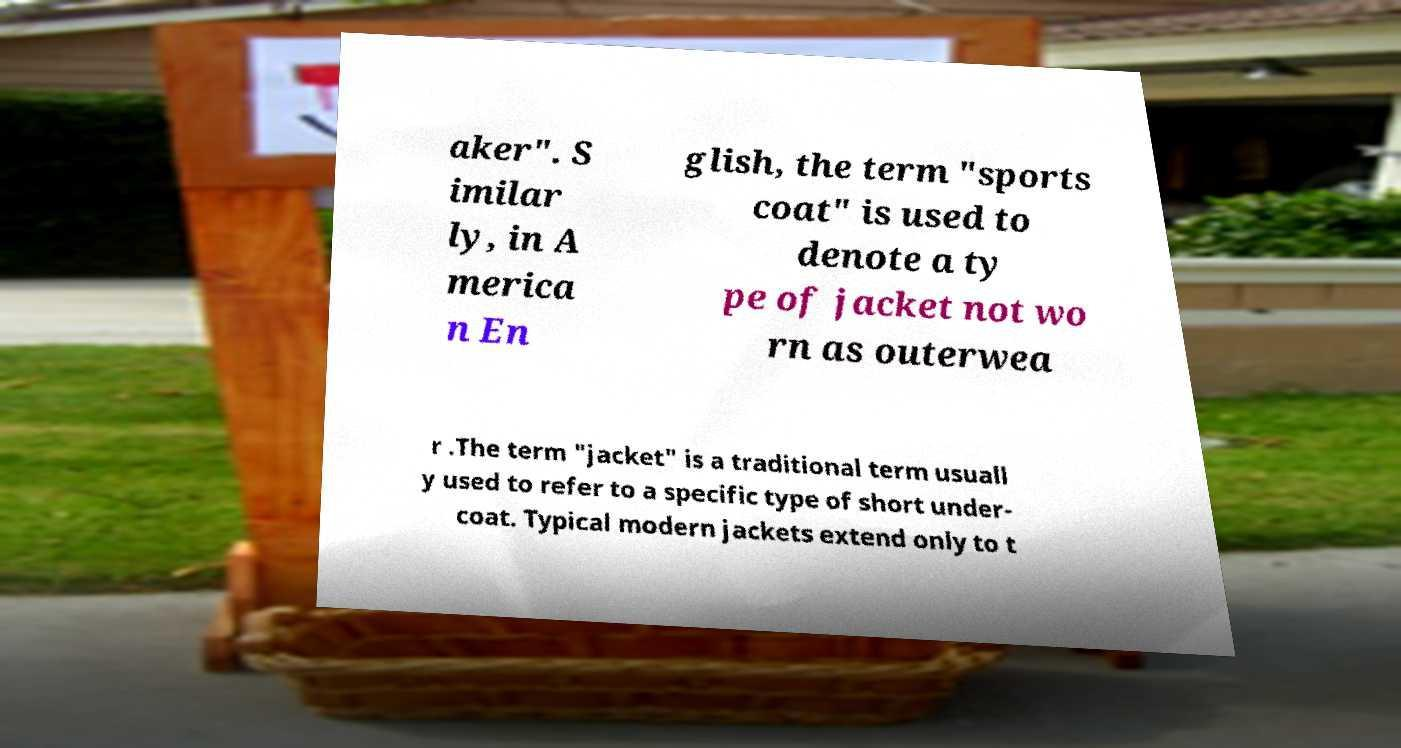For documentation purposes, I need the text within this image transcribed. Could you provide that? aker". S imilar ly, in A merica n En glish, the term "sports coat" is used to denote a ty pe of jacket not wo rn as outerwea r .The term "jacket" is a traditional term usuall y used to refer to a specific type of short under- coat. Typical modern jackets extend only to t 